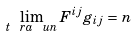Convert formula to latex. <formula><loc_0><loc_0><loc_500><loc_500>\lim _ { t \ r a \ u n } F ^ { i j } g _ { i j } = n</formula> 